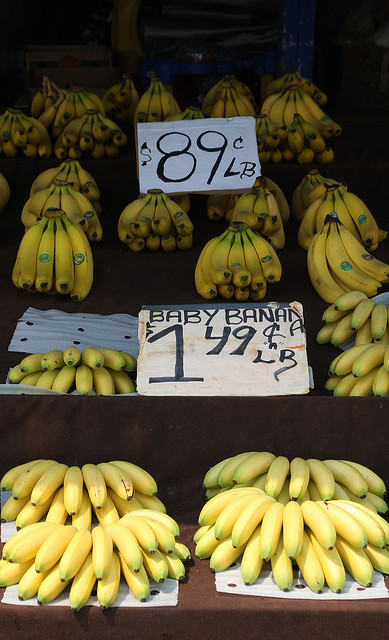<image>Do these fruits grow in Northern Canada? I am not sure if these fruits grow in Northern Canada. It can be both yes or no. Do these fruits grow in Northern Canada? I don't know if these fruits grow in Northern Canada. It seems that most of the answers are 'no', but there is some uncertainty as there is also an 'unknown' answer. 